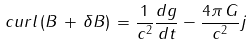<formula> <loc_0><loc_0><loc_500><loc_500>c u r l \, ( { B } \, + \, \delta { B } ) \, = \frac { 1 } { c ^ { 2 } } \frac { d { g } } { d { t } } - \frac { 4 \pi \, G } { c ^ { 2 } } j</formula> 